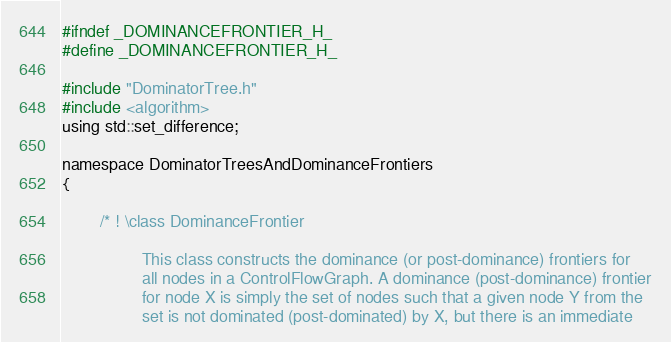Convert code to text. <code><loc_0><loc_0><loc_500><loc_500><_C_>#ifndef _DOMINANCEFRONTIER_H_
#define _DOMINANCEFRONTIER_H_

#include "DominatorTree.h"
#include <algorithm>
using std::set_difference;

namespace DominatorTreesAndDominanceFrontiers
{

        /* ! \class DominanceFrontier

                 This class constructs the dominance (or post-dominance) frontiers for
                 all nodes in a ControlFlowGraph. A dominance (post-dominance) frontier
                 for node X is simply the set of nodes such that a given node Y from the 
                 set is not dominated (post-dominated) by X, but there is an immediate</code> 